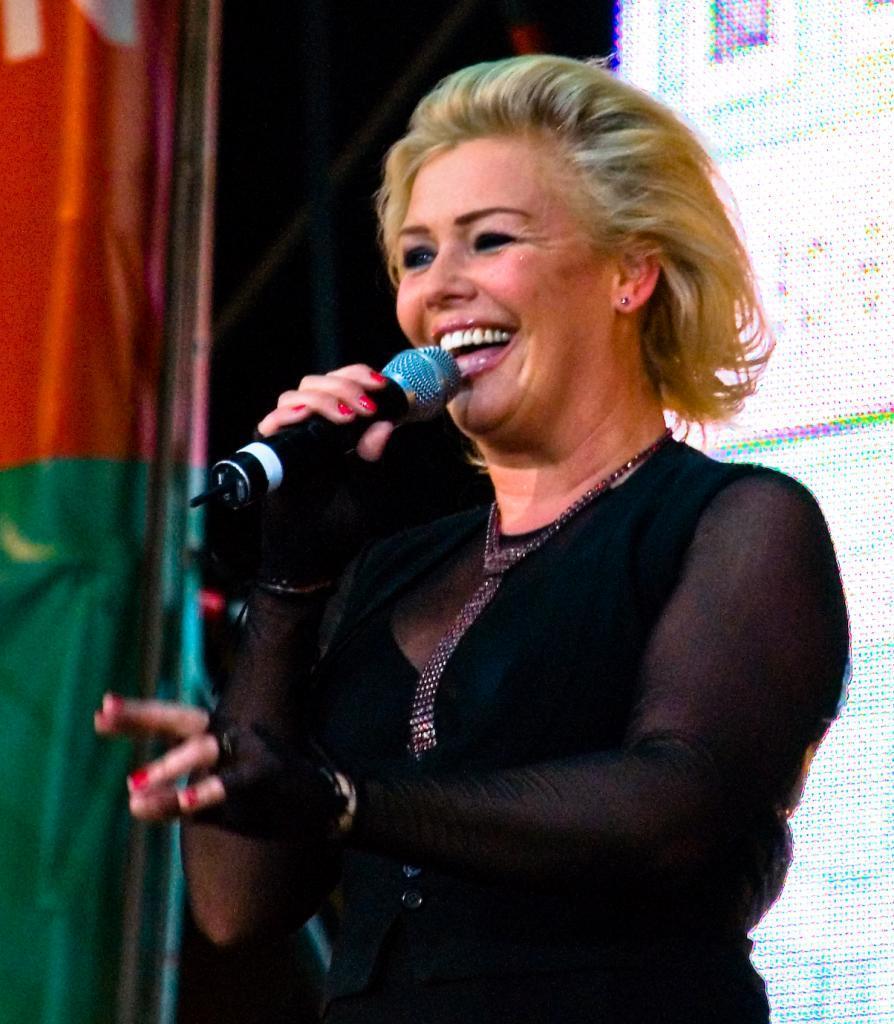Describe this image in one or two sentences. In this Picture we can see that a woman wearing a black dress and singing in the microphone and smiling towards the camera, on the left side we can see big green and yellow color banner and behind we can see led light board. 